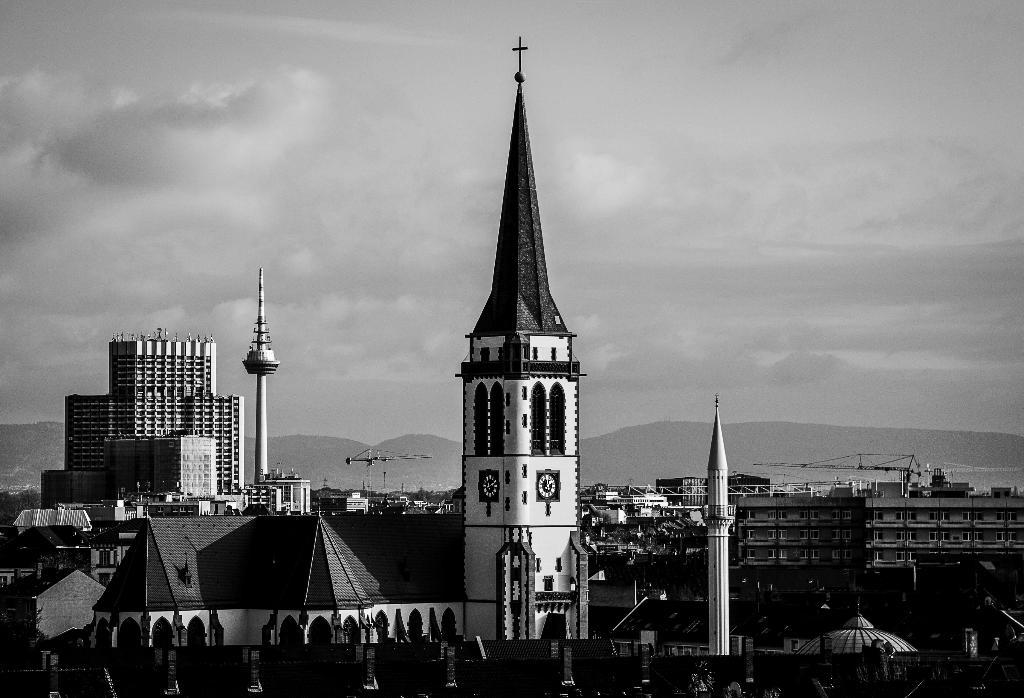What is the main subject in the center of the image? There is a church in the center of the image. What other structures can be seen in the image? There are buildings in the image. Where is the volleyball court located in the image? There is no volleyball court present in the image. Can you see a bucket being used in the image? There is no bucket visible in the image. 